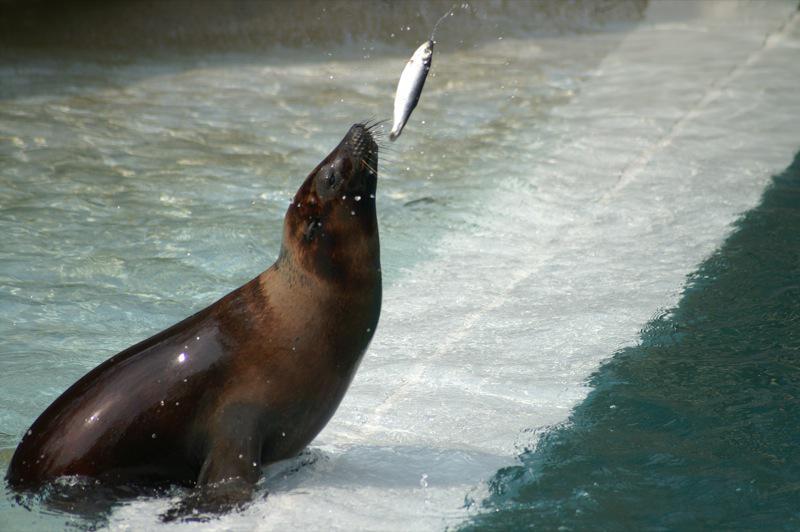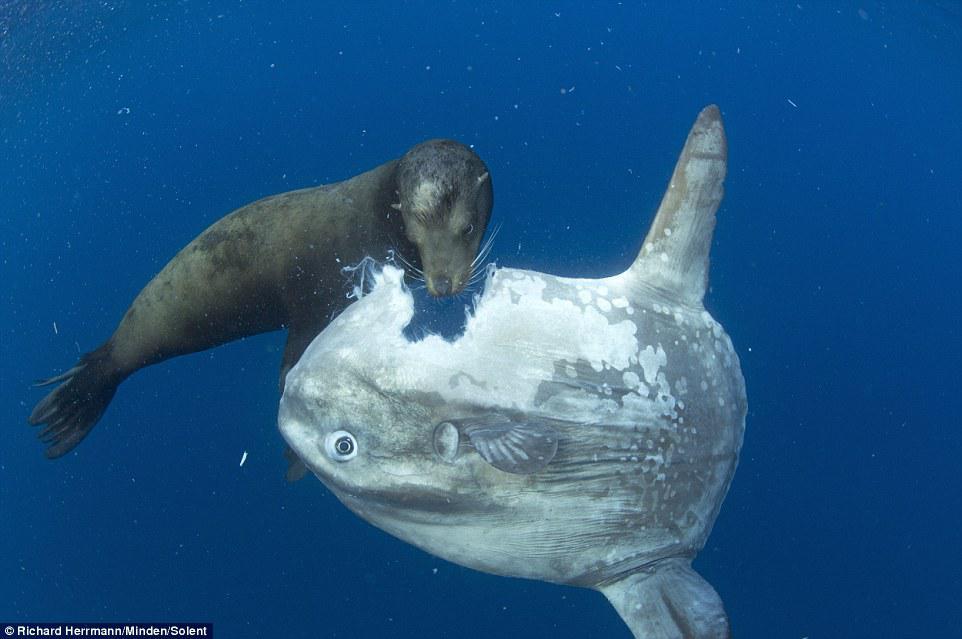The first image is the image on the left, the second image is the image on the right. Considering the images on both sides, is "There is a seal in the water while feeding on a fish in the center of both images" valid? Answer yes or no. No. The first image is the image on the left, the second image is the image on the right. For the images displayed, is the sentence "Each image shows one seal with its head out of water and a fish caught in its mouth, and the seals in the left and right images face the same direction." factually correct? Answer yes or no. No. 